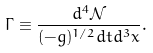<formula> <loc_0><loc_0><loc_500><loc_500>\Gamma \equiv \frac { d ^ { 4 } { \mathcal { N } } } { ( - g ) ^ { 1 / 2 } d t d ^ { 3 } x } .</formula> 